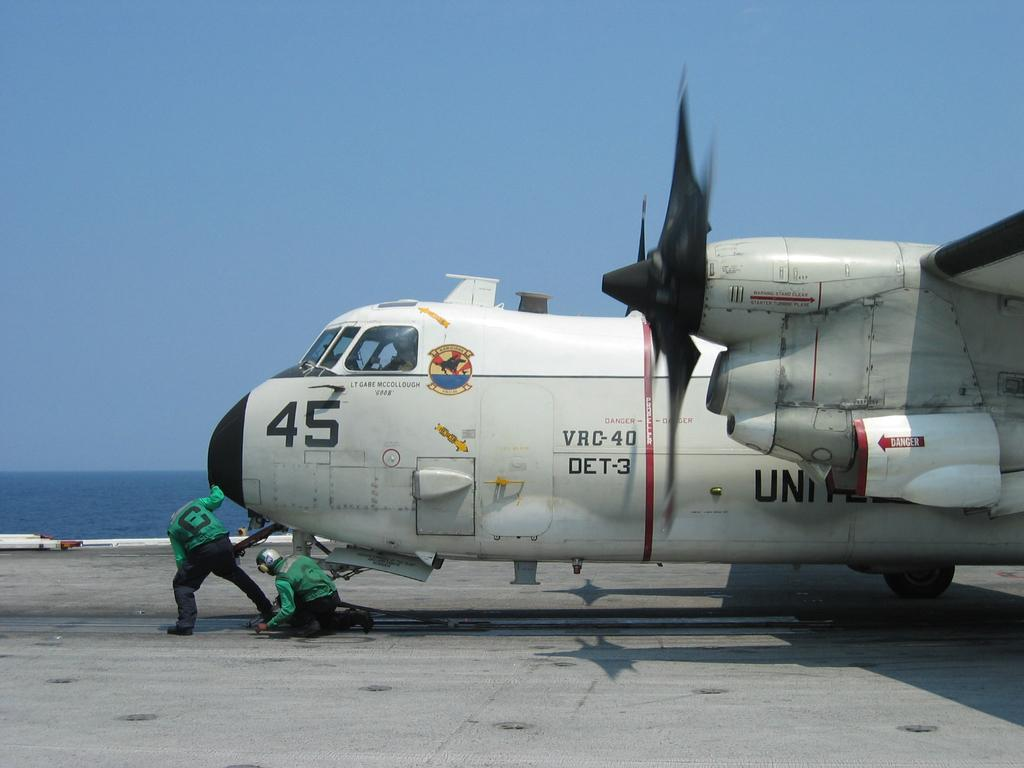What is the main subject of the picture? The main subject of the picture is a jet plane. Who or what is inside the jet plane? A human is sitting in the jet plane. Are there any other people visible in the picture? Yes, there are other humans visible in the picture. What natural element can be seen in the picture? Water is visible in the picture. What is the color of the sky in the picture? The sky is blue in the picture. What rhythm is the human in the jet plane tapping on the window? There is no indication in the image that the human is tapping on the window or following any rhythm. --- 